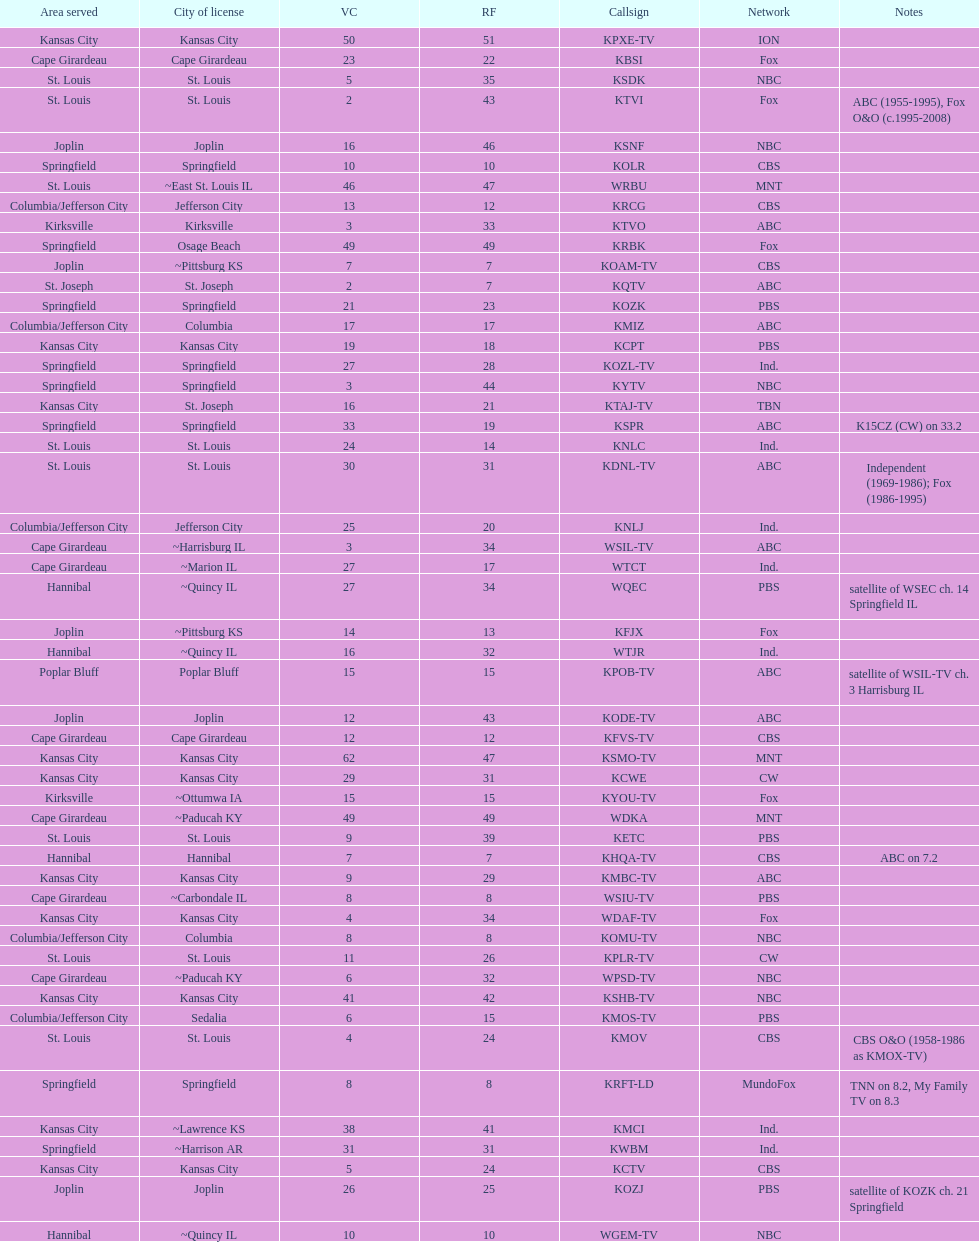What is the total number of stations under the cbs network? 7. 